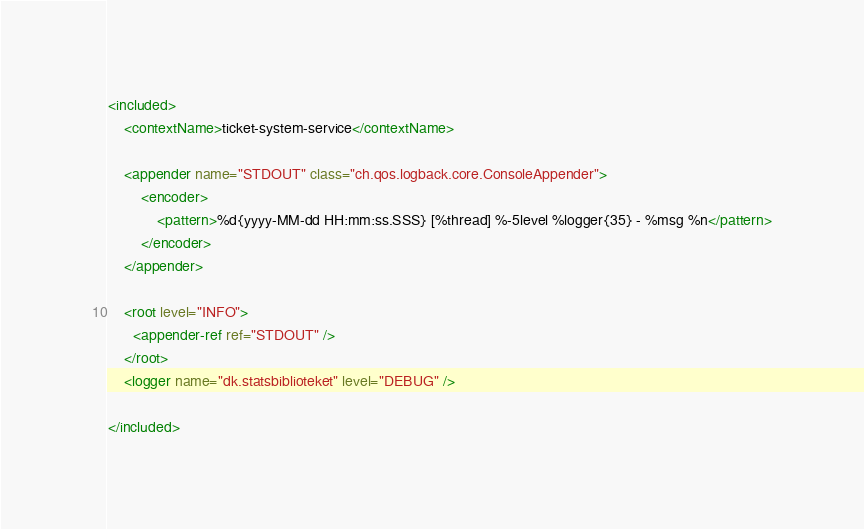<code> <loc_0><loc_0><loc_500><loc_500><_XML_><included>
    <contextName>ticket-system-service</contextName>

    <appender name="STDOUT" class="ch.qos.logback.core.ConsoleAppender">
        <encoder>
            <pattern>%d{yyyy-MM-dd HH:mm:ss.SSS} [%thread] %-5level %logger{35} - %msg %n</pattern>
        </encoder>
    </appender>

    <root level="INFO">
      <appender-ref ref="STDOUT" />
    </root>
    <logger name="dk.statsbiblioteket" level="DEBUG" />
 
</included>

</code> 